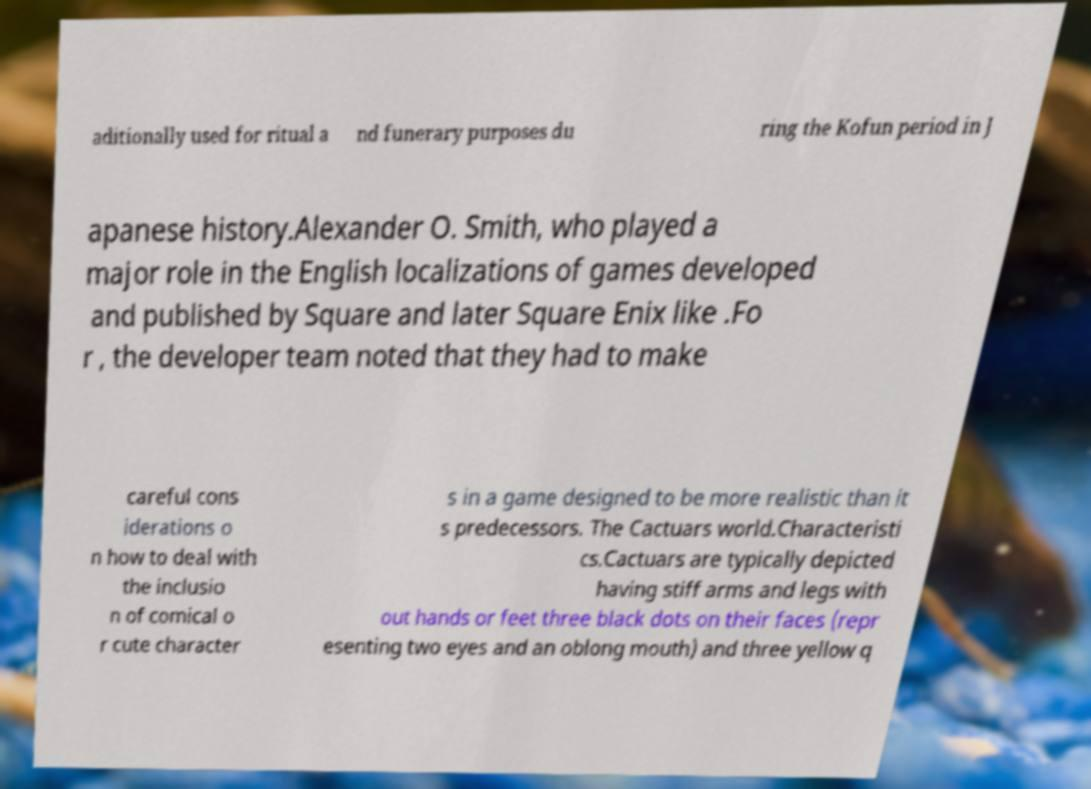Could you assist in decoding the text presented in this image and type it out clearly? aditionally used for ritual a nd funerary purposes du ring the Kofun period in J apanese history.Alexander O. Smith, who played a major role in the English localizations of games developed and published by Square and later Square Enix like .Fo r , the developer team noted that they had to make careful cons iderations o n how to deal with the inclusio n of comical o r cute character s in a game designed to be more realistic than it s predecessors. The Cactuars world.Characteristi cs.Cactuars are typically depicted having stiff arms and legs with out hands or feet three black dots on their faces (repr esenting two eyes and an oblong mouth) and three yellow q 